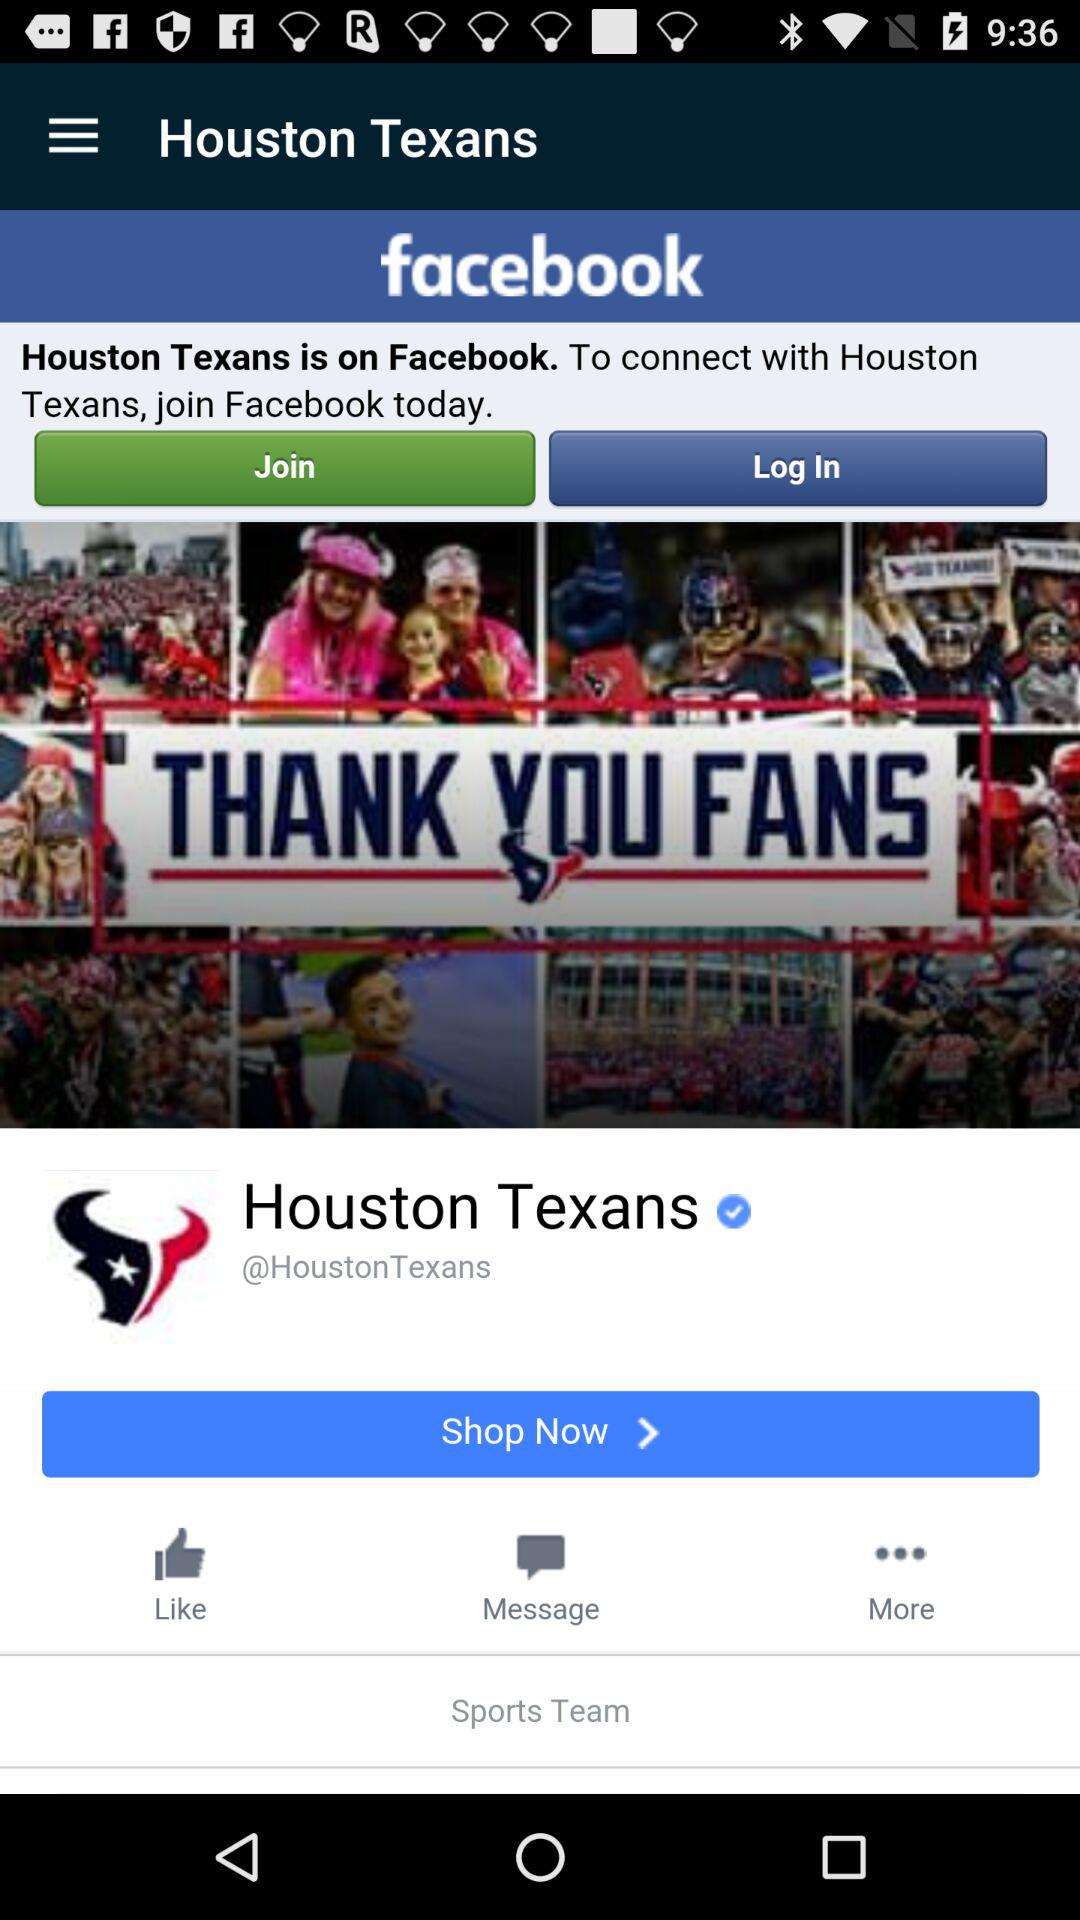What is the application name? The application name is "Houston Texans". 